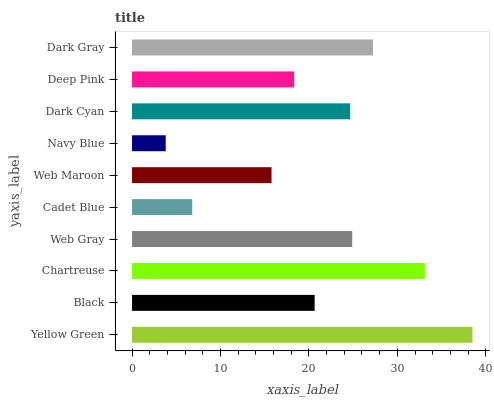Is Navy Blue the minimum?
Answer yes or no. Yes. Is Yellow Green the maximum?
Answer yes or no. Yes. Is Black the minimum?
Answer yes or no. No. Is Black the maximum?
Answer yes or no. No. Is Yellow Green greater than Black?
Answer yes or no. Yes. Is Black less than Yellow Green?
Answer yes or no. Yes. Is Black greater than Yellow Green?
Answer yes or no. No. Is Yellow Green less than Black?
Answer yes or no. No. Is Dark Cyan the high median?
Answer yes or no. Yes. Is Black the low median?
Answer yes or no. Yes. Is Navy Blue the high median?
Answer yes or no. No. Is Chartreuse the low median?
Answer yes or no. No. 